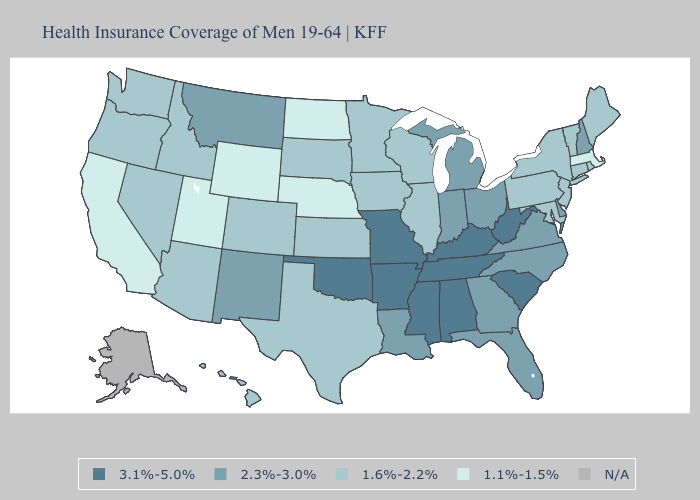Does Wisconsin have the highest value in the MidWest?
Quick response, please. No. What is the lowest value in the USA?
Write a very short answer. 1.1%-1.5%. Name the states that have a value in the range 1.1%-1.5%?
Write a very short answer. California, Massachusetts, Nebraska, North Dakota, Utah, Wyoming. What is the highest value in the USA?
Answer briefly. 3.1%-5.0%. What is the lowest value in the USA?
Concise answer only. 1.1%-1.5%. What is the value of Alaska?
Give a very brief answer. N/A. Does Connecticut have the highest value in the Northeast?
Be succinct. No. What is the highest value in the South ?
Concise answer only. 3.1%-5.0%. What is the value of Maine?
Write a very short answer. 1.6%-2.2%. Name the states that have a value in the range 1.6%-2.2%?
Concise answer only. Arizona, Colorado, Connecticut, Hawaii, Idaho, Illinois, Iowa, Kansas, Maine, Maryland, Minnesota, Nevada, New Jersey, New York, Oregon, Pennsylvania, Rhode Island, South Dakota, Texas, Vermont, Washington, Wisconsin. Name the states that have a value in the range 3.1%-5.0%?
Concise answer only. Alabama, Arkansas, Kentucky, Mississippi, Missouri, Oklahoma, South Carolina, Tennessee, West Virginia. Does Virginia have the highest value in the USA?
Quick response, please. No. How many symbols are there in the legend?
Answer briefly. 5. What is the lowest value in the MidWest?
Be succinct. 1.1%-1.5%. 